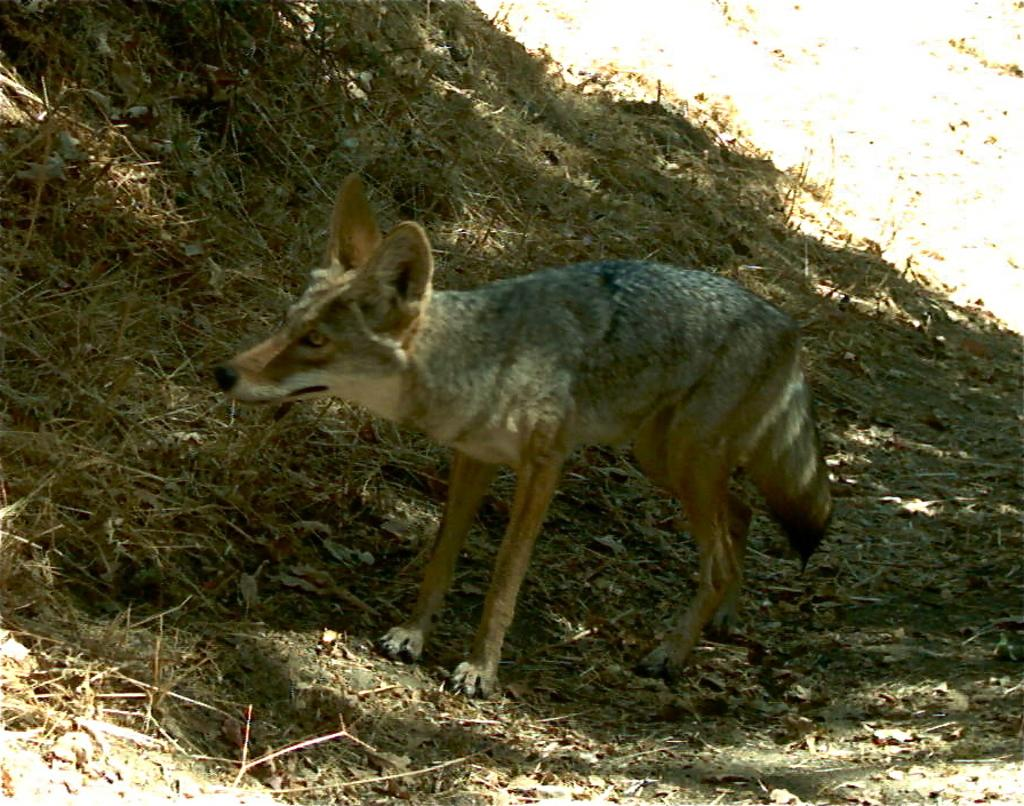What type of living creature can be seen in the image? There is an animal in the image. What type of vegetation is present in the image? There is dried grass in the image. What riddle can be solved by the animal in the image? There is no riddle present in the image, nor is there any indication that the animal is associated with a riddle. 